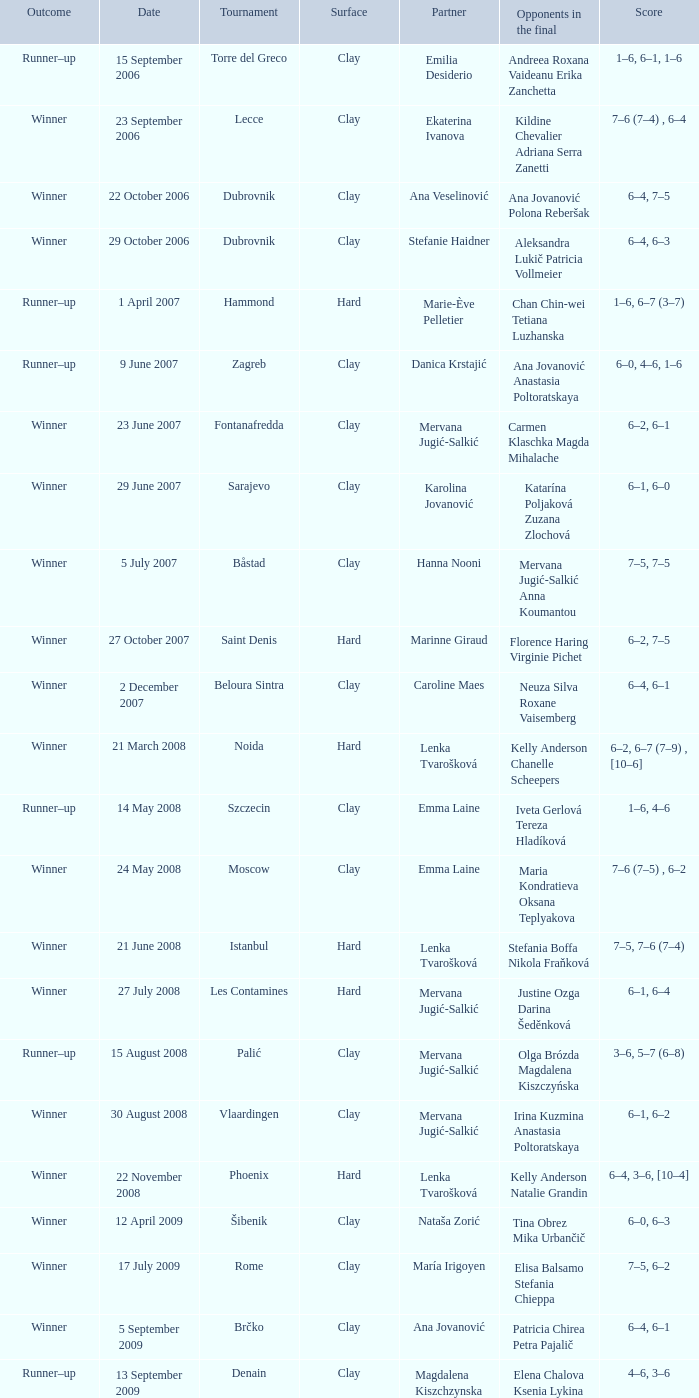Which tournament had a partner of Erika Sema? Aschaffenburg. 